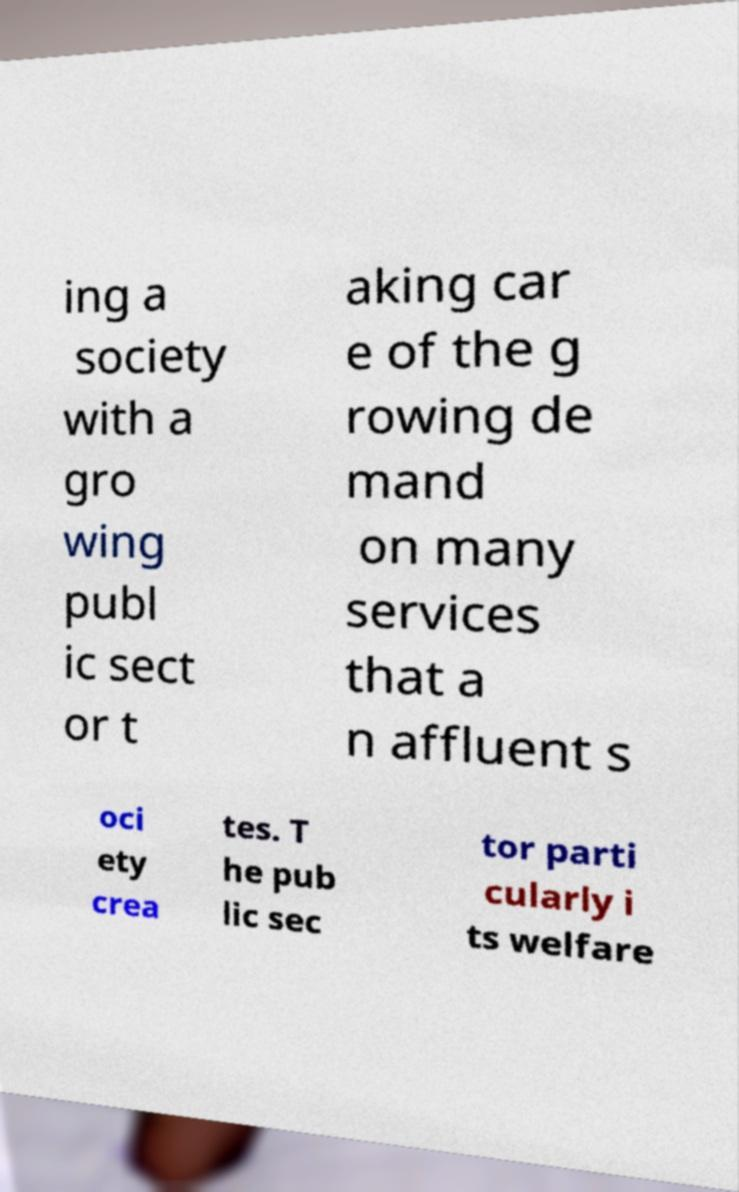Please identify and transcribe the text found in this image. ing a society with a gro wing publ ic sect or t aking car e of the g rowing de mand on many services that a n affluent s oci ety crea tes. T he pub lic sec tor parti cularly i ts welfare 